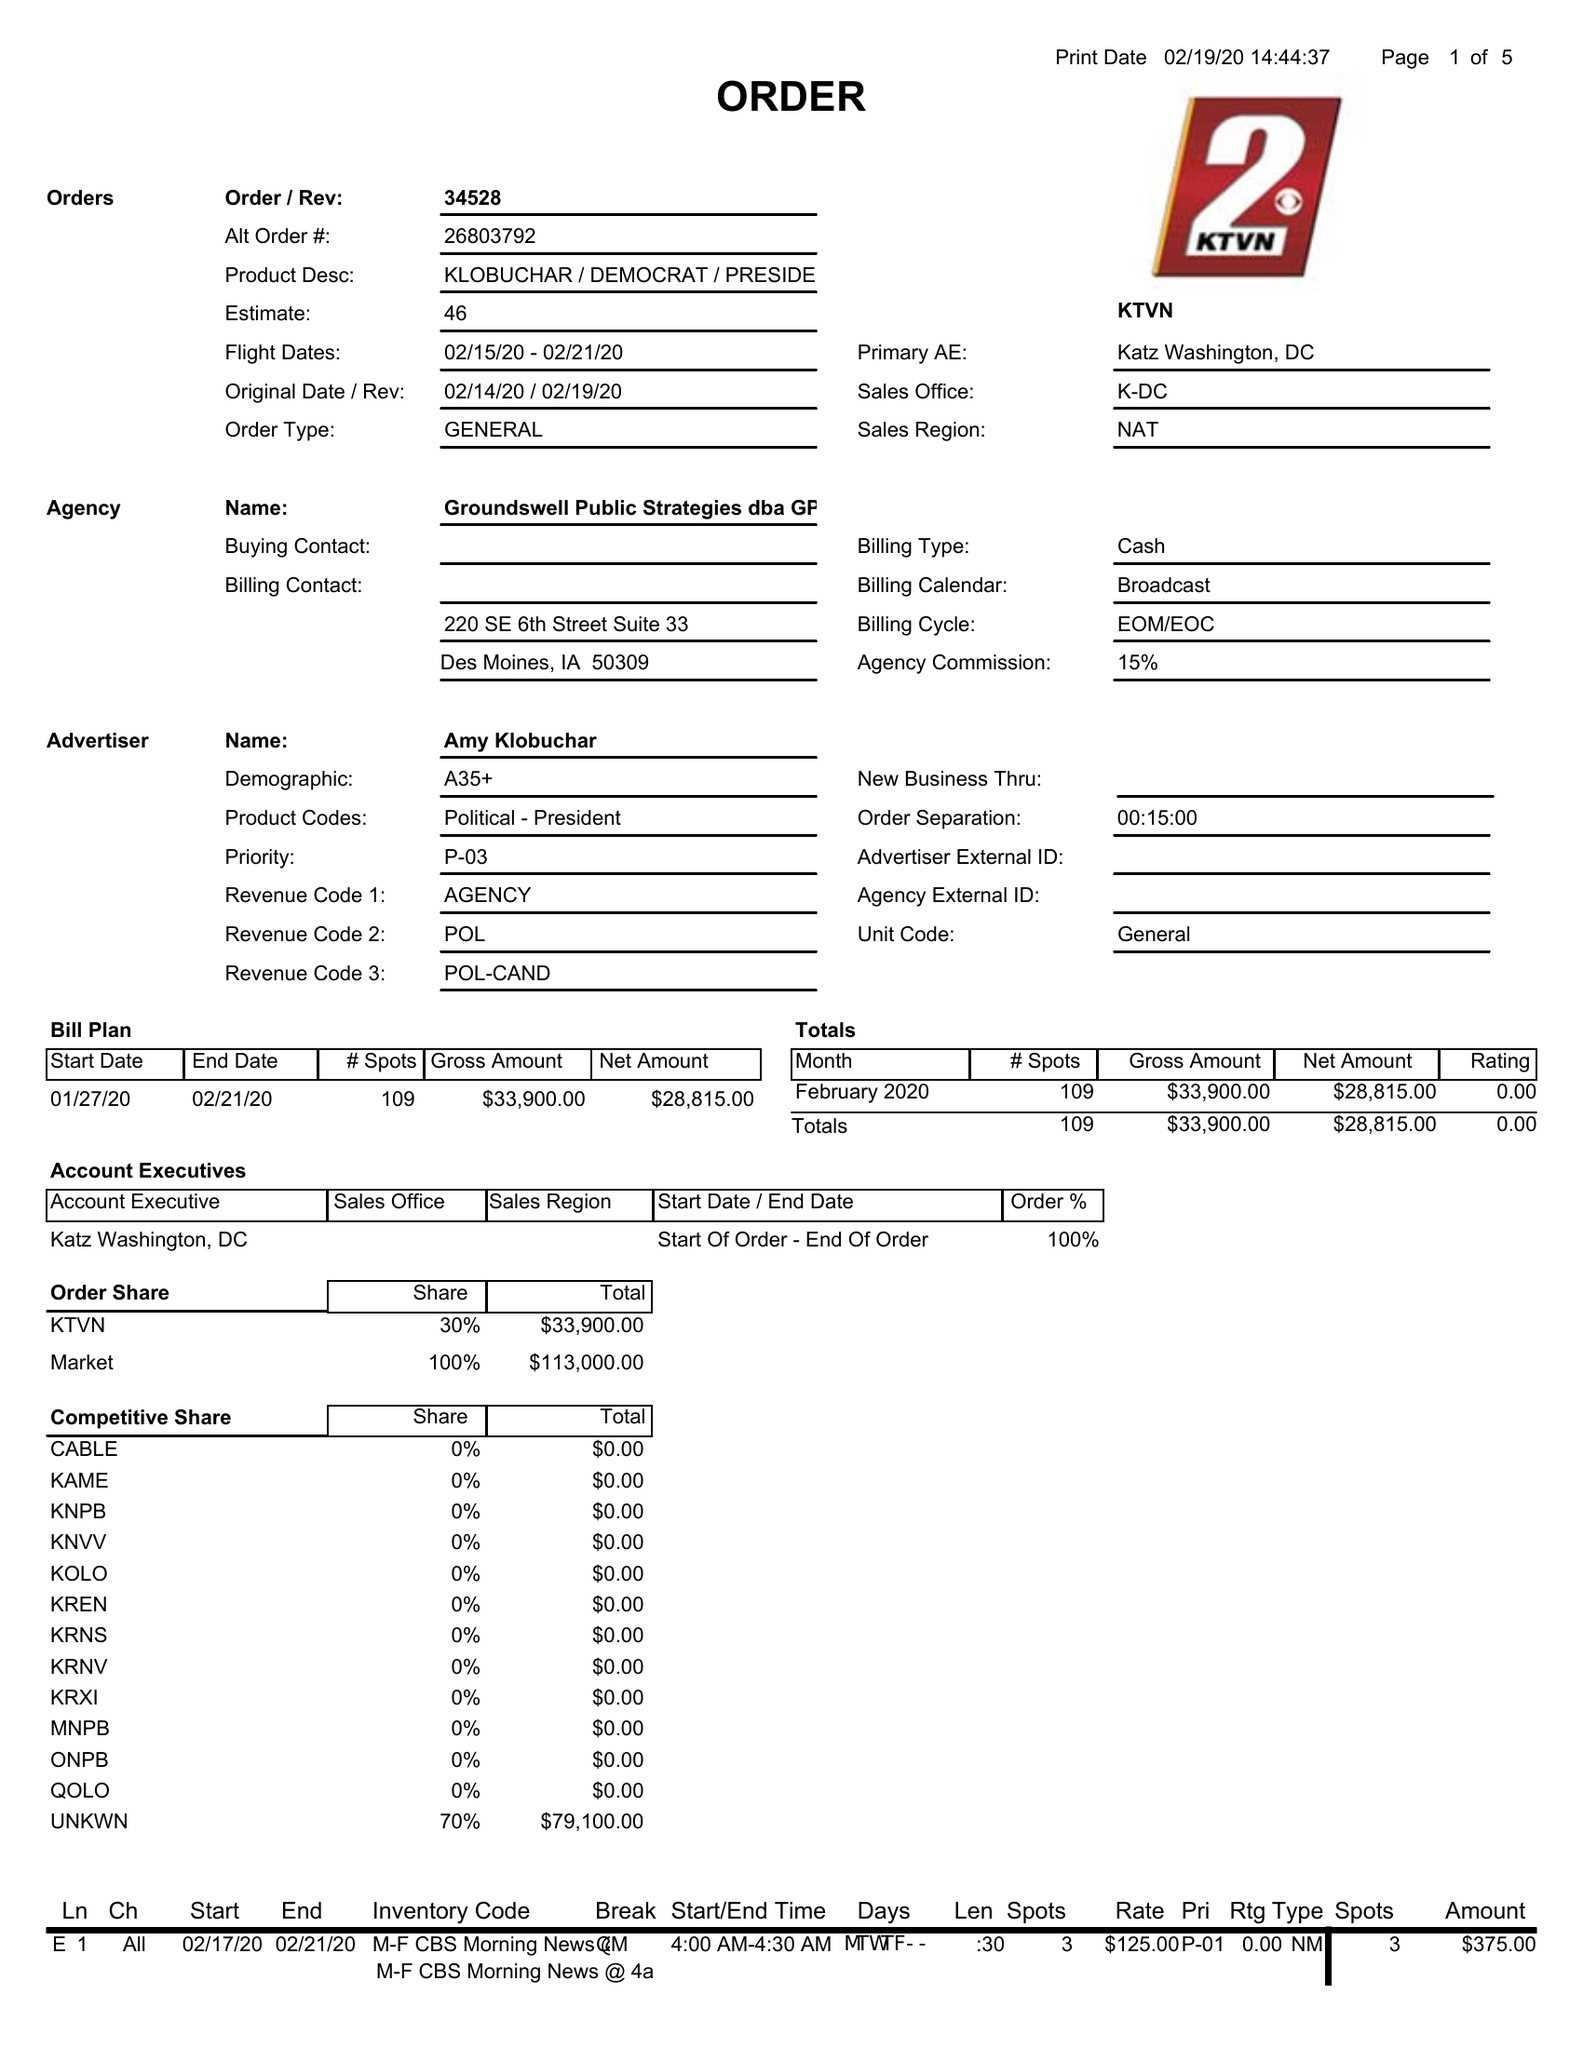What is the value for the gross_amount?
Answer the question using a single word or phrase. 33900.00 